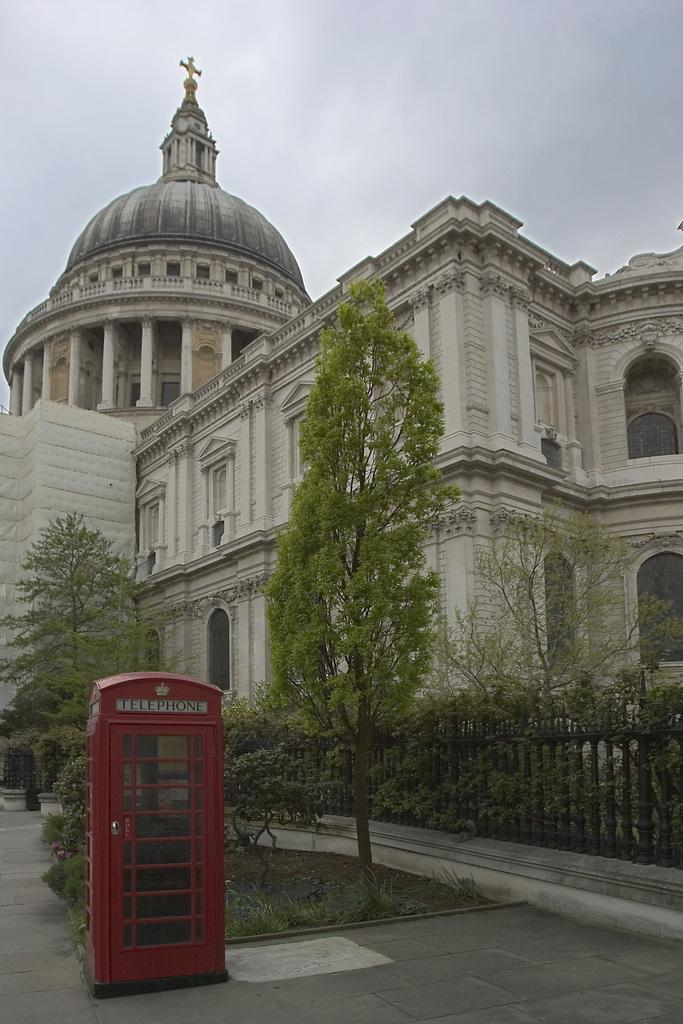What type of structure can be seen in the image? There is a telephone booth in the image. What type of natural elements are present in the image? There are trees and plants visible in the image. What type of man-made structures can be seen in the image? There are buildings in the image. What is visible at the top of the image? The sky is visible in the image. Can you see a dog playing with a cactus in the image? There is no dog or cactus present in the image. What type of weather condition is depicted in the image, such as mist or fog? There is no indication of mist or fog in the image; the sky is visible. 